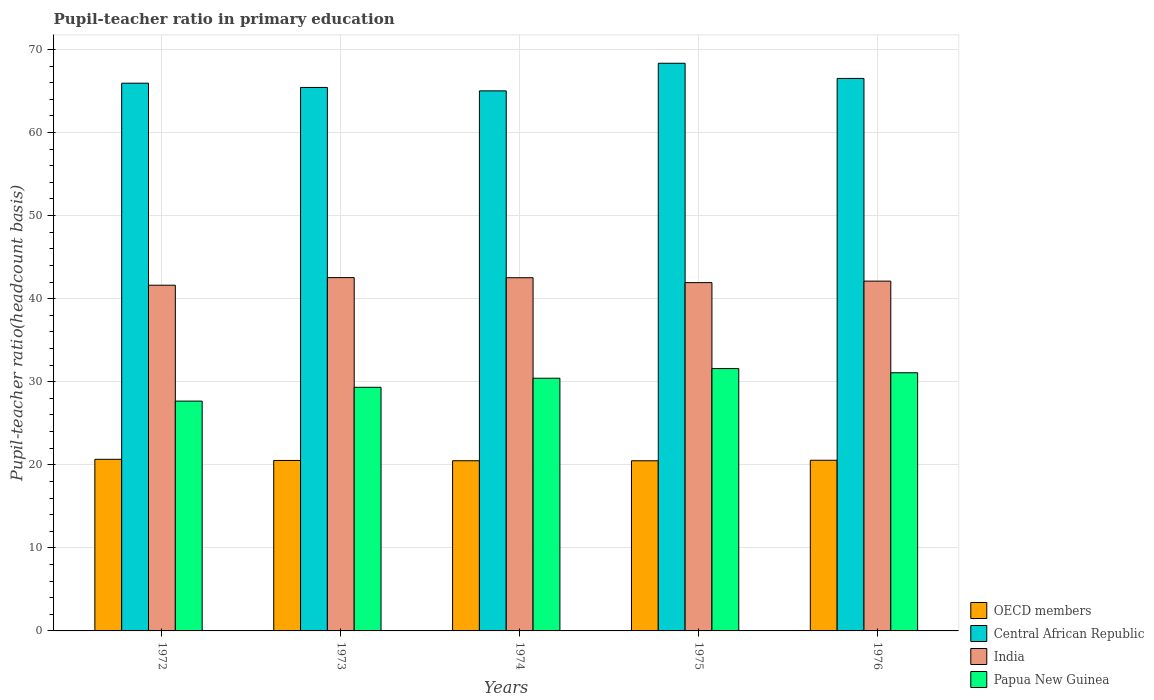How many different coloured bars are there?
Your answer should be very brief. 4. How many groups of bars are there?
Give a very brief answer. 5. How many bars are there on the 4th tick from the left?
Offer a very short reply. 4. How many bars are there on the 1st tick from the right?
Offer a terse response. 4. What is the label of the 5th group of bars from the left?
Offer a very short reply. 1976. What is the pupil-teacher ratio in primary education in Papua New Guinea in 1973?
Your answer should be compact. 29.33. Across all years, what is the maximum pupil-teacher ratio in primary education in OECD members?
Make the answer very short. 20.66. Across all years, what is the minimum pupil-teacher ratio in primary education in OECD members?
Offer a very short reply. 20.48. In which year was the pupil-teacher ratio in primary education in Papua New Guinea maximum?
Keep it short and to the point. 1975. In which year was the pupil-teacher ratio in primary education in India minimum?
Provide a short and direct response. 1972. What is the total pupil-teacher ratio in primary education in OECD members in the graph?
Give a very brief answer. 102.7. What is the difference between the pupil-teacher ratio in primary education in India in 1974 and that in 1975?
Your answer should be compact. 0.59. What is the difference between the pupil-teacher ratio in primary education in Papua New Guinea in 1973 and the pupil-teacher ratio in primary education in OECD members in 1974?
Ensure brevity in your answer.  8.84. What is the average pupil-teacher ratio in primary education in OECD members per year?
Keep it short and to the point. 20.54. In the year 1975, what is the difference between the pupil-teacher ratio in primary education in India and pupil-teacher ratio in primary education in OECD members?
Provide a succinct answer. 21.45. What is the ratio of the pupil-teacher ratio in primary education in India in 1974 to that in 1975?
Ensure brevity in your answer.  1.01. Is the pupil-teacher ratio in primary education in Central African Republic in 1972 less than that in 1976?
Make the answer very short. Yes. Is the difference between the pupil-teacher ratio in primary education in India in 1974 and 1975 greater than the difference between the pupil-teacher ratio in primary education in OECD members in 1974 and 1975?
Make the answer very short. Yes. What is the difference between the highest and the second highest pupil-teacher ratio in primary education in OECD members?
Provide a short and direct response. 0.12. What is the difference between the highest and the lowest pupil-teacher ratio in primary education in India?
Provide a short and direct response. 0.92. In how many years, is the pupil-teacher ratio in primary education in Central African Republic greater than the average pupil-teacher ratio in primary education in Central African Republic taken over all years?
Offer a very short reply. 2. Is the sum of the pupil-teacher ratio in primary education in OECD members in 1972 and 1975 greater than the maximum pupil-teacher ratio in primary education in Central African Republic across all years?
Give a very brief answer. No. What does the 1st bar from the right in 1973 represents?
Give a very brief answer. Papua New Guinea. Is it the case that in every year, the sum of the pupil-teacher ratio in primary education in India and pupil-teacher ratio in primary education in OECD members is greater than the pupil-teacher ratio in primary education in Central African Republic?
Ensure brevity in your answer.  No. Are all the bars in the graph horizontal?
Your answer should be compact. No. How many years are there in the graph?
Make the answer very short. 5. Does the graph contain any zero values?
Provide a short and direct response. No. How are the legend labels stacked?
Offer a terse response. Vertical. What is the title of the graph?
Keep it short and to the point. Pupil-teacher ratio in primary education. Does "Switzerland" appear as one of the legend labels in the graph?
Your answer should be compact. No. What is the label or title of the X-axis?
Give a very brief answer. Years. What is the label or title of the Y-axis?
Your response must be concise. Pupil-teacher ratio(headcount basis). What is the Pupil-teacher ratio(headcount basis) of OECD members in 1972?
Keep it short and to the point. 20.66. What is the Pupil-teacher ratio(headcount basis) of Central African Republic in 1972?
Provide a succinct answer. 65.94. What is the Pupil-teacher ratio(headcount basis) of India in 1972?
Your response must be concise. 41.62. What is the Pupil-teacher ratio(headcount basis) in Papua New Guinea in 1972?
Keep it short and to the point. 27.67. What is the Pupil-teacher ratio(headcount basis) in OECD members in 1973?
Make the answer very short. 20.52. What is the Pupil-teacher ratio(headcount basis) in Central African Republic in 1973?
Offer a very short reply. 65.43. What is the Pupil-teacher ratio(headcount basis) of India in 1973?
Provide a succinct answer. 42.54. What is the Pupil-teacher ratio(headcount basis) in Papua New Guinea in 1973?
Make the answer very short. 29.33. What is the Pupil-teacher ratio(headcount basis) of OECD members in 1974?
Provide a short and direct response. 20.49. What is the Pupil-teacher ratio(headcount basis) in Central African Republic in 1974?
Keep it short and to the point. 65.02. What is the Pupil-teacher ratio(headcount basis) of India in 1974?
Your response must be concise. 42.52. What is the Pupil-teacher ratio(headcount basis) in Papua New Guinea in 1974?
Make the answer very short. 30.42. What is the Pupil-teacher ratio(headcount basis) of OECD members in 1975?
Offer a terse response. 20.48. What is the Pupil-teacher ratio(headcount basis) of Central African Republic in 1975?
Provide a short and direct response. 68.34. What is the Pupil-teacher ratio(headcount basis) in India in 1975?
Your response must be concise. 41.93. What is the Pupil-teacher ratio(headcount basis) in Papua New Guinea in 1975?
Provide a short and direct response. 31.58. What is the Pupil-teacher ratio(headcount basis) in OECD members in 1976?
Your answer should be compact. 20.55. What is the Pupil-teacher ratio(headcount basis) of Central African Republic in 1976?
Offer a terse response. 66.52. What is the Pupil-teacher ratio(headcount basis) of India in 1976?
Make the answer very short. 42.11. What is the Pupil-teacher ratio(headcount basis) in Papua New Guinea in 1976?
Your answer should be compact. 31.08. Across all years, what is the maximum Pupil-teacher ratio(headcount basis) in OECD members?
Offer a terse response. 20.66. Across all years, what is the maximum Pupil-teacher ratio(headcount basis) in Central African Republic?
Offer a very short reply. 68.34. Across all years, what is the maximum Pupil-teacher ratio(headcount basis) in India?
Provide a succinct answer. 42.54. Across all years, what is the maximum Pupil-teacher ratio(headcount basis) of Papua New Guinea?
Make the answer very short. 31.58. Across all years, what is the minimum Pupil-teacher ratio(headcount basis) in OECD members?
Make the answer very short. 20.48. Across all years, what is the minimum Pupil-teacher ratio(headcount basis) of Central African Republic?
Your answer should be very brief. 65.02. Across all years, what is the minimum Pupil-teacher ratio(headcount basis) in India?
Provide a short and direct response. 41.62. Across all years, what is the minimum Pupil-teacher ratio(headcount basis) in Papua New Guinea?
Give a very brief answer. 27.67. What is the total Pupil-teacher ratio(headcount basis) of OECD members in the graph?
Provide a short and direct response. 102.7. What is the total Pupil-teacher ratio(headcount basis) of Central African Republic in the graph?
Keep it short and to the point. 331.24. What is the total Pupil-teacher ratio(headcount basis) in India in the graph?
Provide a short and direct response. 210.72. What is the total Pupil-teacher ratio(headcount basis) in Papua New Guinea in the graph?
Make the answer very short. 150.08. What is the difference between the Pupil-teacher ratio(headcount basis) of OECD members in 1972 and that in 1973?
Make the answer very short. 0.14. What is the difference between the Pupil-teacher ratio(headcount basis) of Central African Republic in 1972 and that in 1973?
Give a very brief answer. 0.51. What is the difference between the Pupil-teacher ratio(headcount basis) in India in 1972 and that in 1973?
Your answer should be compact. -0.92. What is the difference between the Pupil-teacher ratio(headcount basis) in Papua New Guinea in 1972 and that in 1973?
Offer a very short reply. -1.66. What is the difference between the Pupil-teacher ratio(headcount basis) in OECD members in 1972 and that in 1974?
Offer a very short reply. 0.17. What is the difference between the Pupil-teacher ratio(headcount basis) in Central African Republic in 1972 and that in 1974?
Your response must be concise. 0.92. What is the difference between the Pupil-teacher ratio(headcount basis) of India in 1972 and that in 1974?
Make the answer very short. -0.9. What is the difference between the Pupil-teacher ratio(headcount basis) of Papua New Guinea in 1972 and that in 1974?
Give a very brief answer. -2.75. What is the difference between the Pupil-teacher ratio(headcount basis) in OECD members in 1972 and that in 1975?
Your answer should be very brief. 0.18. What is the difference between the Pupil-teacher ratio(headcount basis) of Central African Republic in 1972 and that in 1975?
Ensure brevity in your answer.  -2.4. What is the difference between the Pupil-teacher ratio(headcount basis) of India in 1972 and that in 1975?
Ensure brevity in your answer.  -0.31. What is the difference between the Pupil-teacher ratio(headcount basis) of Papua New Guinea in 1972 and that in 1975?
Your response must be concise. -3.92. What is the difference between the Pupil-teacher ratio(headcount basis) of OECD members in 1972 and that in 1976?
Offer a terse response. 0.12. What is the difference between the Pupil-teacher ratio(headcount basis) of Central African Republic in 1972 and that in 1976?
Ensure brevity in your answer.  -0.58. What is the difference between the Pupil-teacher ratio(headcount basis) of India in 1972 and that in 1976?
Your answer should be compact. -0.49. What is the difference between the Pupil-teacher ratio(headcount basis) of Papua New Guinea in 1972 and that in 1976?
Give a very brief answer. -3.41. What is the difference between the Pupil-teacher ratio(headcount basis) of OECD members in 1973 and that in 1974?
Make the answer very short. 0.04. What is the difference between the Pupil-teacher ratio(headcount basis) of Central African Republic in 1973 and that in 1974?
Offer a terse response. 0.41. What is the difference between the Pupil-teacher ratio(headcount basis) of India in 1973 and that in 1974?
Keep it short and to the point. 0.02. What is the difference between the Pupil-teacher ratio(headcount basis) in Papua New Guinea in 1973 and that in 1974?
Your answer should be compact. -1.09. What is the difference between the Pupil-teacher ratio(headcount basis) in OECD members in 1973 and that in 1975?
Your answer should be compact. 0.04. What is the difference between the Pupil-teacher ratio(headcount basis) of Central African Republic in 1973 and that in 1975?
Provide a short and direct response. -2.91. What is the difference between the Pupil-teacher ratio(headcount basis) of India in 1973 and that in 1975?
Provide a short and direct response. 0.6. What is the difference between the Pupil-teacher ratio(headcount basis) in Papua New Guinea in 1973 and that in 1975?
Your answer should be very brief. -2.25. What is the difference between the Pupil-teacher ratio(headcount basis) in OECD members in 1973 and that in 1976?
Provide a succinct answer. -0.02. What is the difference between the Pupil-teacher ratio(headcount basis) in Central African Republic in 1973 and that in 1976?
Your answer should be very brief. -1.09. What is the difference between the Pupil-teacher ratio(headcount basis) of India in 1973 and that in 1976?
Give a very brief answer. 0.42. What is the difference between the Pupil-teacher ratio(headcount basis) of Papua New Guinea in 1973 and that in 1976?
Make the answer very short. -1.75. What is the difference between the Pupil-teacher ratio(headcount basis) in OECD members in 1974 and that in 1975?
Offer a terse response. 0. What is the difference between the Pupil-teacher ratio(headcount basis) of Central African Republic in 1974 and that in 1975?
Your answer should be compact. -3.32. What is the difference between the Pupil-teacher ratio(headcount basis) of India in 1974 and that in 1975?
Offer a terse response. 0.59. What is the difference between the Pupil-teacher ratio(headcount basis) in Papua New Guinea in 1974 and that in 1975?
Ensure brevity in your answer.  -1.16. What is the difference between the Pupil-teacher ratio(headcount basis) of OECD members in 1974 and that in 1976?
Make the answer very short. -0.06. What is the difference between the Pupil-teacher ratio(headcount basis) of Central African Republic in 1974 and that in 1976?
Ensure brevity in your answer.  -1.5. What is the difference between the Pupil-teacher ratio(headcount basis) in India in 1974 and that in 1976?
Your answer should be compact. 0.41. What is the difference between the Pupil-teacher ratio(headcount basis) in Papua New Guinea in 1974 and that in 1976?
Give a very brief answer. -0.66. What is the difference between the Pupil-teacher ratio(headcount basis) in OECD members in 1975 and that in 1976?
Provide a short and direct response. -0.06. What is the difference between the Pupil-teacher ratio(headcount basis) of Central African Republic in 1975 and that in 1976?
Your response must be concise. 1.82. What is the difference between the Pupil-teacher ratio(headcount basis) of India in 1975 and that in 1976?
Ensure brevity in your answer.  -0.18. What is the difference between the Pupil-teacher ratio(headcount basis) of Papua New Guinea in 1975 and that in 1976?
Your answer should be compact. 0.5. What is the difference between the Pupil-teacher ratio(headcount basis) of OECD members in 1972 and the Pupil-teacher ratio(headcount basis) of Central African Republic in 1973?
Offer a very short reply. -44.77. What is the difference between the Pupil-teacher ratio(headcount basis) in OECD members in 1972 and the Pupil-teacher ratio(headcount basis) in India in 1973?
Your answer should be very brief. -21.87. What is the difference between the Pupil-teacher ratio(headcount basis) in OECD members in 1972 and the Pupil-teacher ratio(headcount basis) in Papua New Guinea in 1973?
Provide a short and direct response. -8.67. What is the difference between the Pupil-teacher ratio(headcount basis) in Central African Republic in 1972 and the Pupil-teacher ratio(headcount basis) in India in 1973?
Ensure brevity in your answer.  23.41. What is the difference between the Pupil-teacher ratio(headcount basis) of Central African Republic in 1972 and the Pupil-teacher ratio(headcount basis) of Papua New Guinea in 1973?
Your response must be concise. 36.61. What is the difference between the Pupil-teacher ratio(headcount basis) in India in 1972 and the Pupil-teacher ratio(headcount basis) in Papua New Guinea in 1973?
Your answer should be compact. 12.29. What is the difference between the Pupil-teacher ratio(headcount basis) in OECD members in 1972 and the Pupil-teacher ratio(headcount basis) in Central African Republic in 1974?
Your response must be concise. -44.36. What is the difference between the Pupil-teacher ratio(headcount basis) in OECD members in 1972 and the Pupil-teacher ratio(headcount basis) in India in 1974?
Provide a short and direct response. -21.86. What is the difference between the Pupil-teacher ratio(headcount basis) of OECD members in 1972 and the Pupil-teacher ratio(headcount basis) of Papua New Guinea in 1974?
Make the answer very short. -9.76. What is the difference between the Pupil-teacher ratio(headcount basis) of Central African Republic in 1972 and the Pupil-teacher ratio(headcount basis) of India in 1974?
Provide a short and direct response. 23.42. What is the difference between the Pupil-teacher ratio(headcount basis) in Central African Republic in 1972 and the Pupil-teacher ratio(headcount basis) in Papua New Guinea in 1974?
Offer a very short reply. 35.52. What is the difference between the Pupil-teacher ratio(headcount basis) in India in 1972 and the Pupil-teacher ratio(headcount basis) in Papua New Guinea in 1974?
Keep it short and to the point. 11.2. What is the difference between the Pupil-teacher ratio(headcount basis) of OECD members in 1972 and the Pupil-teacher ratio(headcount basis) of Central African Republic in 1975?
Provide a succinct answer. -47.68. What is the difference between the Pupil-teacher ratio(headcount basis) in OECD members in 1972 and the Pupil-teacher ratio(headcount basis) in India in 1975?
Your response must be concise. -21.27. What is the difference between the Pupil-teacher ratio(headcount basis) of OECD members in 1972 and the Pupil-teacher ratio(headcount basis) of Papua New Guinea in 1975?
Your answer should be very brief. -10.92. What is the difference between the Pupil-teacher ratio(headcount basis) of Central African Republic in 1972 and the Pupil-teacher ratio(headcount basis) of India in 1975?
Offer a very short reply. 24.01. What is the difference between the Pupil-teacher ratio(headcount basis) in Central African Republic in 1972 and the Pupil-teacher ratio(headcount basis) in Papua New Guinea in 1975?
Your response must be concise. 34.36. What is the difference between the Pupil-teacher ratio(headcount basis) of India in 1972 and the Pupil-teacher ratio(headcount basis) of Papua New Guinea in 1975?
Your answer should be compact. 10.04. What is the difference between the Pupil-teacher ratio(headcount basis) of OECD members in 1972 and the Pupil-teacher ratio(headcount basis) of Central African Republic in 1976?
Keep it short and to the point. -45.86. What is the difference between the Pupil-teacher ratio(headcount basis) of OECD members in 1972 and the Pupil-teacher ratio(headcount basis) of India in 1976?
Provide a succinct answer. -21.45. What is the difference between the Pupil-teacher ratio(headcount basis) in OECD members in 1972 and the Pupil-teacher ratio(headcount basis) in Papua New Guinea in 1976?
Make the answer very short. -10.42. What is the difference between the Pupil-teacher ratio(headcount basis) in Central African Republic in 1972 and the Pupil-teacher ratio(headcount basis) in India in 1976?
Your response must be concise. 23.83. What is the difference between the Pupil-teacher ratio(headcount basis) in Central African Republic in 1972 and the Pupil-teacher ratio(headcount basis) in Papua New Guinea in 1976?
Your response must be concise. 34.86. What is the difference between the Pupil-teacher ratio(headcount basis) of India in 1972 and the Pupil-teacher ratio(headcount basis) of Papua New Guinea in 1976?
Give a very brief answer. 10.54. What is the difference between the Pupil-teacher ratio(headcount basis) of OECD members in 1973 and the Pupil-teacher ratio(headcount basis) of Central African Republic in 1974?
Ensure brevity in your answer.  -44.49. What is the difference between the Pupil-teacher ratio(headcount basis) in OECD members in 1973 and the Pupil-teacher ratio(headcount basis) in India in 1974?
Ensure brevity in your answer.  -22. What is the difference between the Pupil-teacher ratio(headcount basis) in OECD members in 1973 and the Pupil-teacher ratio(headcount basis) in Papua New Guinea in 1974?
Offer a terse response. -9.9. What is the difference between the Pupil-teacher ratio(headcount basis) of Central African Republic in 1973 and the Pupil-teacher ratio(headcount basis) of India in 1974?
Provide a succinct answer. 22.91. What is the difference between the Pupil-teacher ratio(headcount basis) of Central African Republic in 1973 and the Pupil-teacher ratio(headcount basis) of Papua New Guinea in 1974?
Provide a succinct answer. 35.01. What is the difference between the Pupil-teacher ratio(headcount basis) of India in 1973 and the Pupil-teacher ratio(headcount basis) of Papua New Guinea in 1974?
Provide a succinct answer. 12.11. What is the difference between the Pupil-teacher ratio(headcount basis) of OECD members in 1973 and the Pupil-teacher ratio(headcount basis) of Central African Republic in 1975?
Provide a short and direct response. -47.82. What is the difference between the Pupil-teacher ratio(headcount basis) in OECD members in 1973 and the Pupil-teacher ratio(headcount basis) in India in 1975?
Offer a very short reply. -21.41. What is the difference between the Pupil-teacher ratio(headcount basis) of OECD members in 1973 and the Pupil-teacher ratio(headcount basis) of Papua New Guinea in 1975?
Your response must be concise. -11.06. What is the difference between the Pupil-teacher ratio(headcount basis) of Central African Republic in 1973 and the Pupil-teacher ratio(headcount basis) of India in 1975?
Offer a terse response. 23.5. What is the difference between the Pupil-teacher ratio(headcount basis) of Central African Republic in 1973 and the Pupil-teacher ratio(headcount basis) of Papua New Guinea in 1975?
Give a very brief answer. 33.85. What is the difference between the Pupil-teacher ratio(headcount basis) in India in 1973 and the Pupil-teacher ratio(headcount basis) in Papua New Guinea in 1975?
Your response must be concise. 10.95. What is the difference between the Pupil-teacher ratio(headcount basis) of OECD members in 1973 and the Pupil-teacher ratio(headcount basis) of Central African Republic in 1976?
Ensure brevity in your answer.  -45.99. What is the difference between the Pupil-teacher ratio(headcount basis) of OECD members in 1973 and the Pupil-teacher ratio(headcount basis) of India in 1976?
Ensure brevity in your answer.  -21.59. What is the difference between the Pupil-teacher ratio(headcount basis) in OECD members in 1973 and the Pupil-teacher ratio(headcount basis) in Papua New Guinea in 1976?
Keep it short and to the point. -10.55. What is the difference between the Pupil-teacher ratio(headcount basis) in Central African Republic in 1973 and the Pupil-teacher ratio(headcount basis) in India in 1976?
Provide a succinct answer. 23.32. What is the difference between the Pupil-teacher ratio(headcount basis) of Central African Republic in 1973 and the Pupil-teacher ratio(headcount basis) of Papua New Guinea in 1976?
Give a very brief answer. 34.35. What is the difference between the Pupil-teacher ratio(headcount basis) of India in 1973 and the Pupil-teacher ratio(headcount basis) of Papua New Guinea in 1976?
Your response must be concise. 11.46. What is the difference between the Pupil-teacher ratio(headcount basis) in OECD members in 1974 and the Pupil-teacher ratio(headcount basis) in Central African Republic in 1975?
Offer a terse response. -47.85. What is the difference between the Pupil-teacher ratio(headcount basis) in OECD members in 1974 and the Pupil-teacher ratio(headcount basis) in India in 1975?
Offer a very short reply. -21.44. What is the difference between the Pupil-teacher ratio(headcount basis) in OECD members in 1974 and the Pupil-teacher ratio(headcount basis) in Papua New Guinea in 1975?
Offer a very short reply. -11.1. What is the difference between the Pupil-teacher ratio(headcount basis) in Central African Republic in 1974 and the Pupil-teacher ratio(headcount basis) in India in 1975?
Provide a short and direct response. 23.08. What is the difference between the Pupil-teacher ratio(headcount basis) of Central African Republic in 1974 and the Pupil-teacher ratio(headcount basis) of Papua New Guinea in 1975?
Ensure brevity in your answer.  33.43. What is the difference between the Pupil-teacher ratio(headcount basis) in India in 1974 and the Pupil-teacher ratio(headcount basis) in Papua New Guinea in 1975?
Provide a succinct answer. 10.94. What is the difference between the Pupil-teacher ratio(headcount basis) in OECD members in 1974 and the Pupil-teacher ratio(headcount basis) in Central African Republic in 1976?
Give a very brief answer. -46.03. What is the difference between the Pupil-teacher ratio(headcount basis) in OECD members in 1974 and the Pupil-teacher ratio(headcount basis) in India in 1976?
Your response must be concise. -21.63. What is the difference between the Pupil-teacher ratio(headcount basis) of OECD members in 1974 and the Pupil-teacher ratio(headcount basis) of Papua New Guinea in 1976?
Give a very brief answer. -10.59. What is the difference between the Pupil-teacher ratio(headcount basis) in Central African Republic in 1974 and the Pupil-teacher ratio(headcount basis) in India in 1976?
Provide a short and direct response. 22.9. What is the difference between the Pupil-teacher ratio(headcount basis) of Central African Republic in 1974 and the Pupil-teacher ratio(headcount basis) of Papua New Guinea in 1976?
Give a very brief answer. 33.94. What is the difference between the Pupil-teacher ratio(headcount basis) in India in 1974 and the Pupil-teacher ratio(headcount basis) in Papua New Guinea in 1976?
Provide a succinct answer. 11.44. What is the difference between the Pupil-teacher ratio(headcount basis) in OECD members in 1975 and the Pupil-teacher ratio(headcount basis) in Central African Republic in 1976?
Your answer should be compact. -46.03. What is the difference between the Pupil-teacher ratio(headcount basis) of OECD members in 1975 and the Pupil-teacher ratio(headcount basis) of India in 1976?
Provide a succinct answer. -21.63. What is the difference between the Pupil-teacher ratio(headcount basis) of OECD members in 1975 and the Pupil-teacher ratio(headcount basis) of Papua New Guinea in 1976?
Your answer should be very brief. -10.6. What is the difference between the Pupil-teacher ratio(headcount basis) in Central African Republic in 1975 and the Pupil-teacher ratio(headcount basis) in India in 1976?
Your response must be concise. 26.23. What is the difference between the Pupil-teacher ratio(headcount basis) in Central African Republic in 1975 and the Pupil-teacher ratio(headcount basis) in Papua New Guinea in 1976?
Make the answer very short. 37.26. What is the difference between the Pupil-teacher ratio(headcount basis) of India in 1975 and the Pupil-teacher ratio(headcount basis) of Papua New Guinea in 1976?
Your answer should be compact. 10.85. What is the average Pupil-teacher ratio(headcount basis) of OECD members per year?
Ensure brevity in your answer.  20.54. What is the average Pupil-teacher ratio(headcount basis) in Central African Republic per year?
Provide a succinct answer. 66.25. What is the average Pupil-teacher ratio(headcount basis) of India per year?
Make the answer very short. 42.14. What is the average Pupil-teacher ratio(headcount basis) of Papua New Guinea per year?
Keep it short and to the point. 30.02. In the year 1972, what is the difference between the Pupil-teacher ratio(headcount basis) in OECD members and Pupil-teacher ratio(headcount basis) in Central African Republic?
Keep it short and to the point. -45.28. In the year 1972, what is the difference between the Pupil-teacher ratio(headcount basis) of OECD members and Pupil-teacher ratio(headcount basis) of India?
Ensure brevity in your answer.  -20.96. In the year 1972, what is the difference between the Pupil-teacher ratio(headcount basis) in OECD members and Pupil-teacher ratio(headcount basis) in Papua New Guinea?
Provide a short and direct response. -7.01. In the year 1972, what is the difference between the Pupil-teacher ratio(headcount basis) of Central African Republic and Pupil-teacher ratio(headcount basis) of India?
Ensure brevity in your answer.  24.32. In the year 1972, what is the difference between the Pupil-teacher ratio(headcount basis) in Central African Republic and Pupil-teacher ratio(headcount basis) in Papua New Guinea?
Keep it short and to the point. 38.27. In the year 1972, what is the difference between the Pupil-teacher ratio(headcount basis) in India and Pupil-teacher ratio(headcount basis) in Papua New Guinea?
Make the answer very short. 13.95. In the year 1973, what is the difference between the Pupil-teacher ratio(headcount basis) of OECD members and Pupil-teacher ratio(headcount basis) of Central African Republic?
Your answer should be compact. -44.9. In the year 1973, what is the difference between the Pupil-teacher ratio(headcount basis) in OECD members and Pupil-teacher ratio(headcount basis) in India?
Offer a very short reply. -22.01. In the year 1973, what is the difference between the Pupil-teacher ratio(headcount basis) of OECD members and Pupil-teacher ratio(headcount basis) of Papua New Guinea?
Your answer should be very brief. -8.81. In the year 1973, what is the difference between the Pupil-teacher ratio(headcount basis) in Central African Republic and Pupil-teacher ratio(headcount basis) in India?
Provide a short and direct response. 22.89. In the year 1973, what is the difference between the Pupil-teacher ratio(headcount basis) in Central African Republic and Pupil-teacher ratio(headcount basis) in Papua New Guinea?
Provide a succinct answer. 36.1. In the year 1973, what is the difference between the Pupil-teacher ratio(headcount basis) in India and Pupil-teacher ratio(headcount basis) in Papua New Guinea?
Keep it short and to the point. 13.2. In the year 1974, what is the difference between the Pupil-teacher ratio(headcount basis) in OECD members and Pupil-teacher ratio(headcount basis) in Central African Republic?
Your answer should be very brief. -44.53. In the year 1974, what is the difference between the Pupil-teacher ratio(headcount basis) of OECD members and Pupil-teacher ratio(headcount basis) of India?
Give a very brief answer. -22.03. In the year 1974, what is the difference between the Pupil-teacher ratio(headcount basis) of OECD members and Pupil-teacher ratio(headcount basis) of Papua New Guinea?
Keep it short and to the point. -9.93. In the year 1974, what is the difference between the Pupil-teacher ratio(headcount basis) in Central African Republic and Pupil-teacher ratio(headcount basis) in India?
Keep it short and to the point. 22.5. In the year 1974, what is the difference between the Pupil-teacher ratio(headcount basis) in Central African Republic and Pupil-teacher ratio(headcount basis) in Papua New Guinea?
Keep it short and to the point. 34.6. In the year 1974, what is the difference between the Pupil-teacher ratio(headcount basis) in India and Pupil-teacher ratio(headcount basis) in Papua New Guinea?
Your answer should be very brief. 12.1. In the year 1975, what is the difference between the Pupil-teacher ratio(headcount basis) of OECD members and Pupil-teacher ratio(headcount basis) of Central African Republic?
Make the answer very short. -47.86. In the year 1975, what is the difference between the Pupil-teacher ratio(headcount basis) of OECD members and Pupil-teacher ratio(headcount basis) of India?
Give a very brief answer. -21.45. In the year 1975, what is the difference between the Pupil-teacher ratio(headcount basis) of OECD members and Pupil-teacher ratio(headcount basis) of Papua New Guinea?
Your answer should be compact. -11.1. In the year 1975, what is the difference between the Pupil-teacher ratio(headcount basis) in Central African Republic and Pupil-teacher ratio(headcount basis) in India?
Your answer should be compact. 26.41. In the year 1975, what is the difference between the Pupil-teacher ratio(headcount basis) of Central African Republic and Pupil-teacher ratio(headcount basis) of Papua New Guinea?
Your response must be concise. 36.76. In the year 1975, what is the difference between the Pupil-teacher ratio(headcount basis) in India and Pupil-teacher ratio(headcount basis) in Papua New Guinea?
Keep it short and to the point. 10.35. In the year 1976, what is the difference between the Pupil-teacher ratio(headcount basis) in OECD members and Pupil-teacher ratio(headcount basis) in Central African Republic?
Provide a succinct answer. -45.97. In the year 1976, what is the difference between the Pupil-teacher ratio(headcount basis) in OECD members and Pupil-teacher ratio(headcount basis) in India?
Give a very brief answer. -21.57. In the year 1976, what is the difference between the Pupil-teacher ratio(headcount basis) in OECD members and Pupil-teacher ratio(headcount basis) in Papua New Guinea?
Your response must be concise. -10.53. In the year 1976, what is the difference between the Pupil-teacher ratio(headcount basis) of Central African Republic and Pupil-teacher ratio(headcount basis) of India?
Your answer should be compact. 24.4. In the year 1976, what is the difference between the Pupil-teacher ratio(headcount basis) in Central African Republic and Pupil-teacher ratio(headcount basis) in Papua New Guinea?
Make the answer very short. 35.44. In the year 1976, what is the difference between the Pupil-teacher ratio(headcount basis) in India and Pupil-teacher ratio(headcount basis) in Papua New Guinea?
Offer a terse response. 11.03. What is the ratio of the Pupil-teacher ratio(headcount basis) in OECD members in 1972 to that in 1973?
Give a very brief answer. 1.01. What is the ratio of the Pupil-teacher ratio(headcount basis) of India in 1972 to that in 1973?
Offer a very short reply. 0.98. What is the ratio of the Pupil-teacher ratio(headcount basis) in Papua New Guinea in 1972 to that in 1973?
Make the answer very short. 0.94. What is the ratio of the Pupil-teacher ratio(headcount basis) in OECD members in 1972 to that in 1974?
Keep it short and to the point. 1.01. What is the ratio of the Pupil-teacher ratio(headcount basis) in Central African Republic in 1972 to that in 1974?
Your response must be concise. 1.01. What is the ratio of the Pupil-teacher ratio(headcount basis) in India in 1972 to that in 1974?
Your answer should be very brief. 0.98. What is the ratio of the Pupil-teacher ratio(headcount basis) in Papua New Guinea in 1972 to that in 1974?
Give a very brief answer. 0.91. What is the ratio of the Pupil-teacher ratio(headcount basis) in OECD members in 1972 to that in 1975?
Offer a very short reply. 1.01. What is the ratio of the Pupil-teacher ratio(headcount basis) of Central African Republic in 1972 to that in 1975?
Provide a short and direct response. 0.96. What is the ratio of the Pupil-teacher ratio(headcount basis) of Papua New Guinea in 1972 to that in 1975?
Keep it short and to the point. 0.88. What is the ratio of the Pupil-teacher ratio(headcount basis) in OECD members in 1972 to that in 1976?
Make the answer very short. 1.01. What is the ratio of the Pupil-teacher ratio(headcount basis) of India in 1972 to that in 1976?
Offer a terse response. 0.99. What is the ratio of the Pupil-teacher ratio(headcount basis) in Papua New Guinea in 1972 to that in 1976?
Provide a short and direct response. 0.89. What is the ratio of the Pupil-teacher ratio(headcount basis) of OECD members in 1973 to that in 1974?
Keep it short and to the point. 1. What is the ratio of the Pupil-teacher ratio(headcount basis) of India in 1973 to that in 1974?
Make the answer very short. 1. What is the ratio of the Pupil-teacher ratio(headcount basis) of Papua New Guinea in 1973 to that in 1974?
Offer a very short reply. 0.96. What is the ratio of the Pupil-teacher ratio(headcount basis) of Central African Republic in 1973 to that in 1975?
Offer a terse response. 0.96. What is the ratio of the Pupil-teacher ratio(headcount basis) of India in 1973 to that in 1975?
Your response must be concise. 1.01. What is the ratio of the Pupil-teacher ratio(headcount basis) of Papua New Guinea in 1973 to that in 1975?
Keep it short and to the point. 0.93. What is the ratio of the Pupil-teacher ratio(headcount basis) in OECD members in 1973 to that in 1976?
Your response must be concise. 1. What is the ratio of the Pupil-teacher ratio(headcount basis) in Central African Republic in 1973 to that in 1976?
Make the answer very short. 0.98. What is the ratio of the Pupil-teacher ratio(headcount basis) of Papua New Guinea in 1973 to that in 1976?
Your answer should be very brief. 0.94. What is the ratio of the Pupil-teacher ratio(headcount basis) of Central African Republic in 1974 to that in 1975?
Give a very brief answer. 0.95. What is the ratio of the Pupil-teacher ratio(headcount basis) in Papua New Guinea in 1974 to that in 1975?
Your answer should be very brief. 0.96. What is the ratio of the Pupil-teacher ratio(headcount basis) in Central African Republic in 1974 to that in 1976?
Offer a very short reply. 0.98. What is the ratio of the Pupil-teacher ratio(headcount basis) in India in 1974 to that in 1976?
Provide a succinct answer. 1.01. What is the ratio of the Pupil-teacher ratio(headcount basis) in Papua New Guinea in 1974 to that in 1976?
Offer a very short reply. 0.98. What is the ratio of the Pupil-teacher ratio(headcount basis) of Central African Republic in 1975 to that in 1976?
Ensure brevity in your answer.  1.03. What is the ratio of the Pupil-teacher ratio(headcount basis) in Papua New Guinea in 1975 to that in 1976?
Make the answer very short. 1.02. What is the difference between the highest and the second highest Pupil-teacher ratio(headcount basis) in OECD members?
Your answer should be compact. 0.12. What is the difference between the highest and the second highest Pupil-teacher ratio(headcount basis) of Central African Republic?
Your response must be concise. 1.82. What is the difference between the highest and the second highest Pupil-teacher ratio(headcount basis) of India?
Offer a very short reply. 0.02. What is the difference between the highest and the second highest Pupil-teacher ratio(headcount basis) in Papua New Guinea?
Offer a very short reply. 0.5. What is the difference between the highest and the lowest Pupil-teacher ratio(headcount basis) in OECD members?
Offer a terse response. 0.18. What is the difference between the highest and the lowest Pupil-teacher ratio(headcount basis) of Central African Republic?
Make the answer very short. 3.32. What is the difference between the highest and the lowest Pupil-teacher ratio(headcount basis) in India?
Keep it short and to the point. 0.92. What is the difference between the highest and the lowest Pupil-teacher ratio(headcount basis) of Papua New Guinea?
Ensure brevity in your answer.  3.92. 